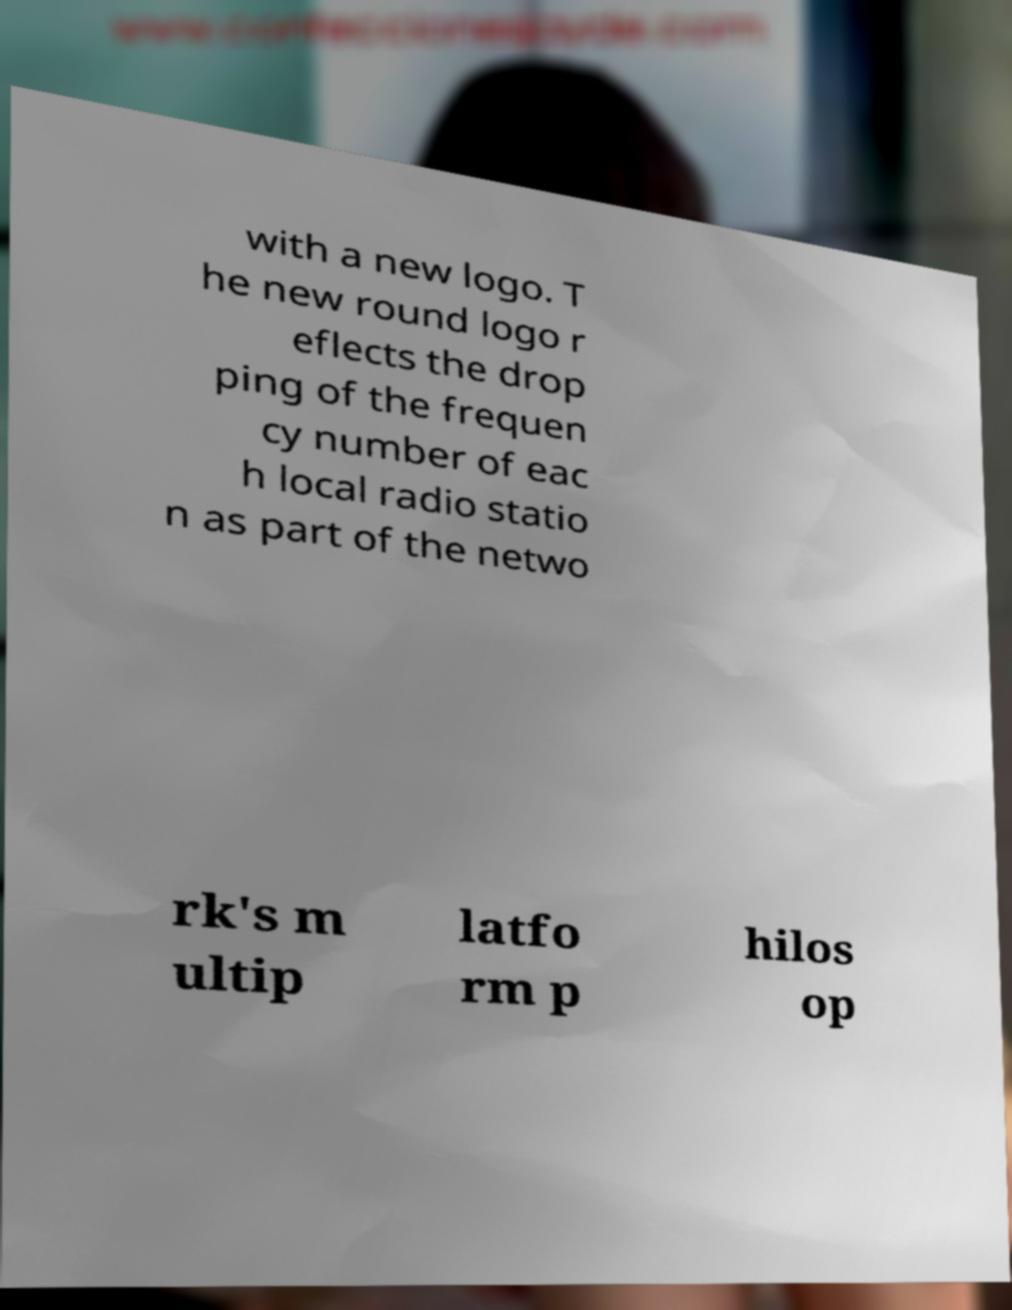Please read and relay the text visible in this image. What does it say? with a new logo. T he new round logo r eflects the drop ping of the frequen cy number of eac h local radio statio n as part of the netwo rk's m ultip latfo rm p hilos op 